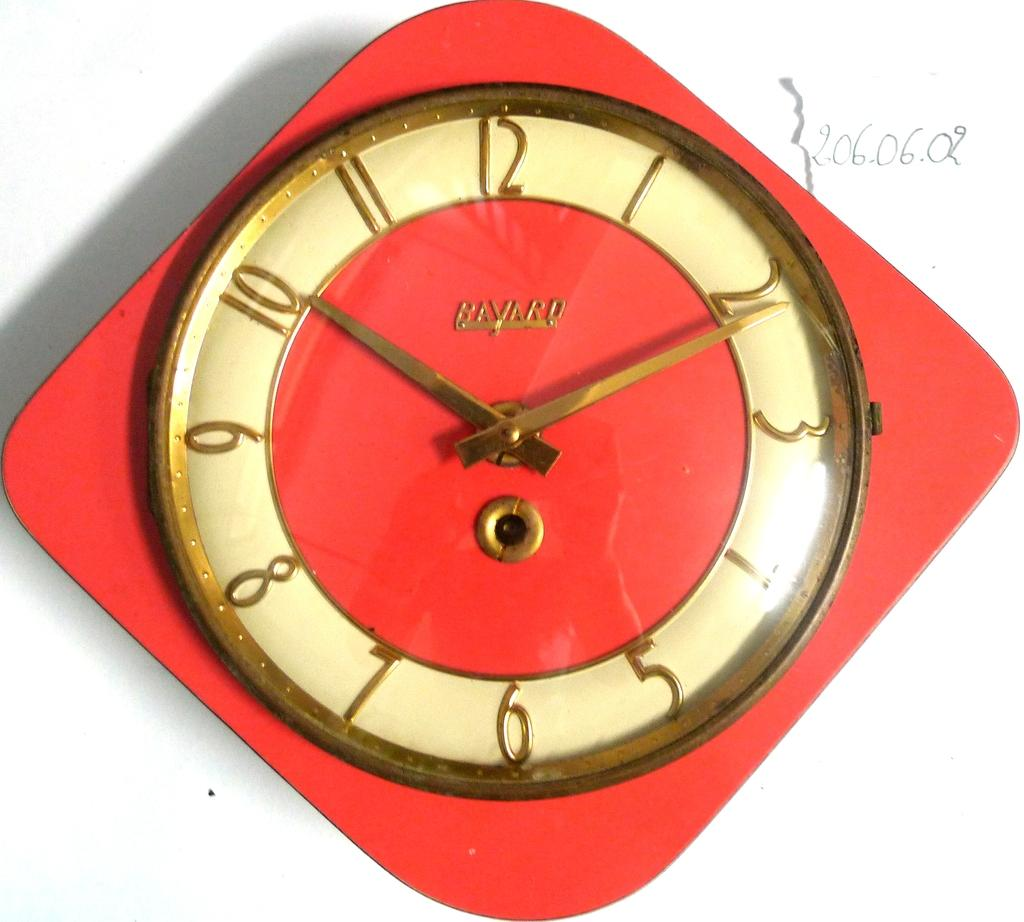<image>
Relay a brief, clear account of the picture shown. A red clock with the word Bavard visible 